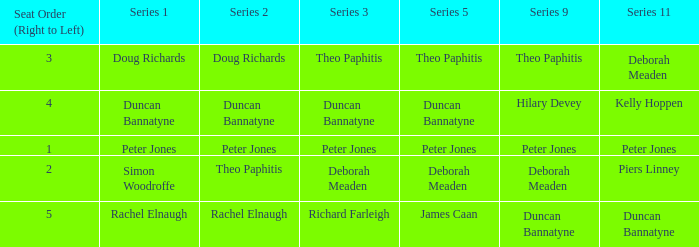Which Series 2 has a Series 3 of deborah meaden? Theo Paphitis. 